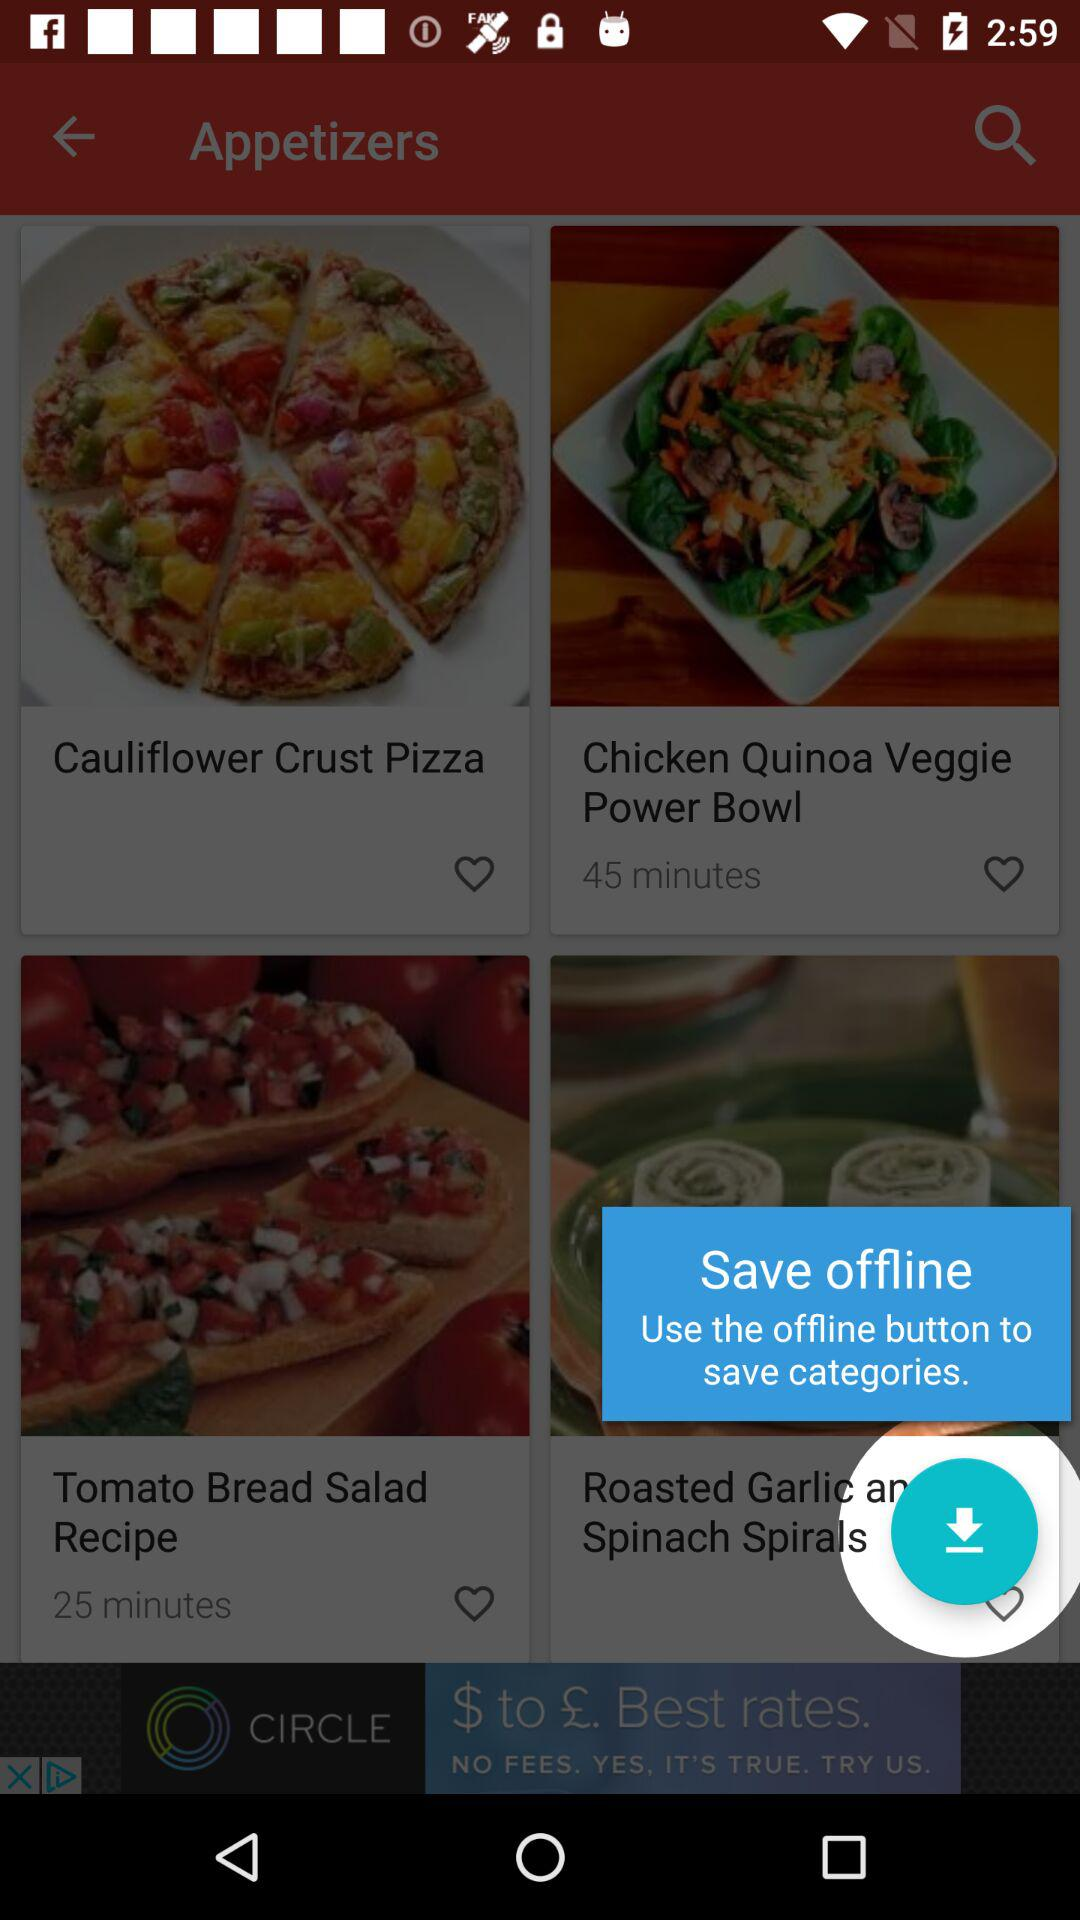How long will it take to make a "Chicken Quinoa Veggie Power Bowl"? It will take 45 minutes. 